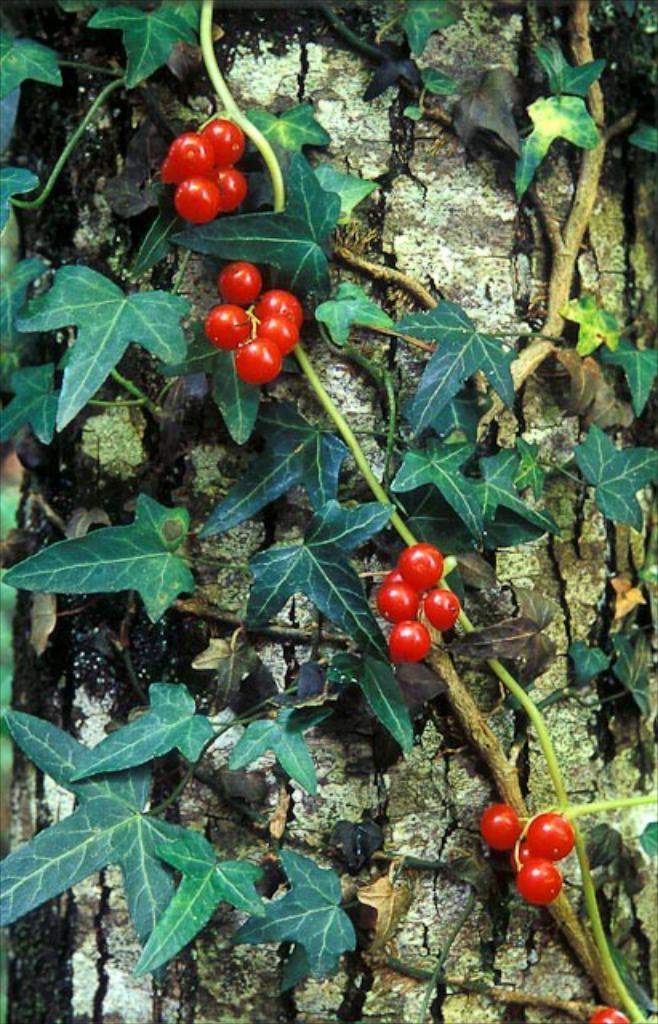What type of plants are attached to the trunk in the image? The plants attached to the trunk in the image are not specified, but they are connected to the trunk. Can you describe the red object in the image? There is a red object in the image that resembles a cherry. What is the chance of finding an alley in the image? There is no alley present in the image, so it is not possible to determine the chance of finding one. 